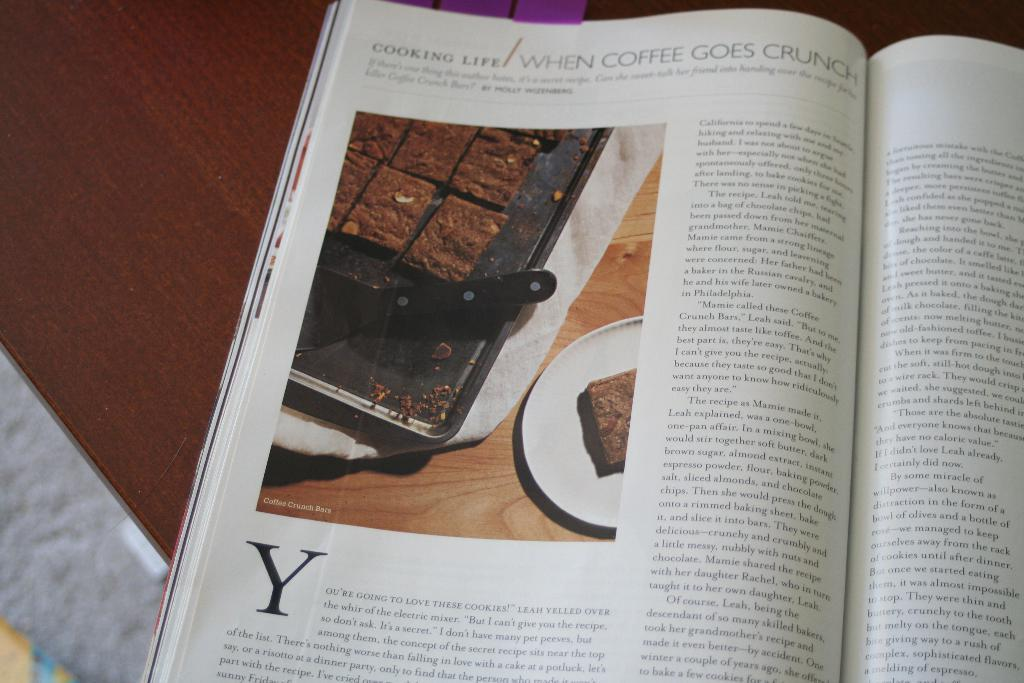<image>
Render a clear and concise summary of the photo. A magazine is open to a page with a picture of coffee crunch bars on it. 